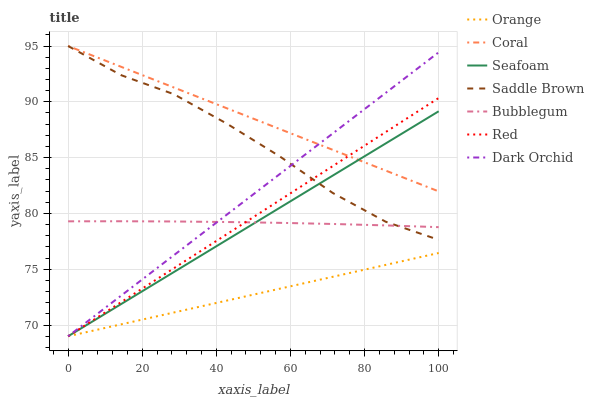Does Orange have the minimum area under the curve?
Answer yes or no. Yes. Does Coral have the maximum area under the curve?
Answer yes or no. Yes. Does Seafoam have the minimum area under the curve?
Answer yes or no. No. Does Seafoam have the maximum area under the curve?
Answer yes or no. No. Is Seafoam the smoothest?
Answer yes or no. Yes. Is Saddle Brown the roughest?
Answer yes or no. Yes. Is Bubblegum the smoothest?
Answer yes or no. No. Is Bubblegum the roughest?
Answer yes or no. No. Does Bubblegum have the lowest value?
Answer yes or no. No. Does Saddle Brown have the highest value?
Answer yes or no. Yes. Does Seafoam have the highest value?
Answer yes or no. No. Is Bubblegum less than Coral?
Answer yes or no. Yes. Is Coral greater than Bubblegum?
Answer yes or no. Yes. Does Red intersect Saddle Brown?
Answer yes or no. Yes. Is Red less than Saddle Brown?
Answer yes or no. No. Is Red greater than Saddle Brown?
Answer yes or no. No. Does Bubblegum intersect Coral?
Answer yes or no. No. 